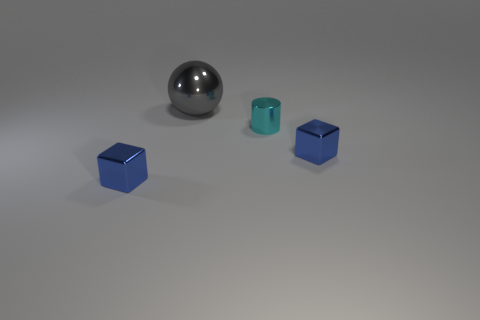Add 4 small blue metallic objects. How many objects exist? 8 Subtract all cylinders. How many objects are left? 3 Add 4 small metal objects. How many small metal objects exist? 7 Subtract 0 gray blocks. How many objects are left? 4 Subtract all tiny blue things. Subtract all blue metal cubes. How many objects are left? 0 Add 2 cyan cylinders. How many cyan cylinders are left? 3 